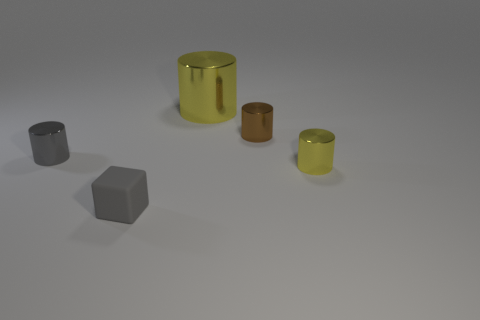What number of tiny things are either gray rubber objects or gray shiny objects?
Make the answer very short. 2. What is the shape of the small yellow thing that is the same material as the brown object?
Ensure brevity in your answer.  Cylinder. There is a yellow metal cylinder that is on the right side of the tiny brown metallic cylinder; what is its size?
Offer a very short reply. Small. What shape is the small brown thing?
Make the answer very short. Cylinder. There is a yellow thing behind the brown shiny thing; is its size the same as the gray object that is right of the tiny gray cylinder?
Offer a very short reply. No. How big is the cylinder on the left side of the yellow cylinder behind the yellow object right of the big yellow metallic object?
Offer a terse response. Small. What is the shape of the tiny object that is in front of the yellow cylinder that is in front of the gray thing behind the matte cube?
Ensure brevity in your answer.  Cube. What shape is the yellow metallic thing to the right of the big yellow shiny cylinder?
Your response must be concise. Cylinder. Is the material of the small gray cylinder the same as the yellow cylinder in front of the brown shiny thing?
Give a very brief answer. Yes. How many other things are the same shape as the brown metal thing?
Provide a succinct answer. 3. 